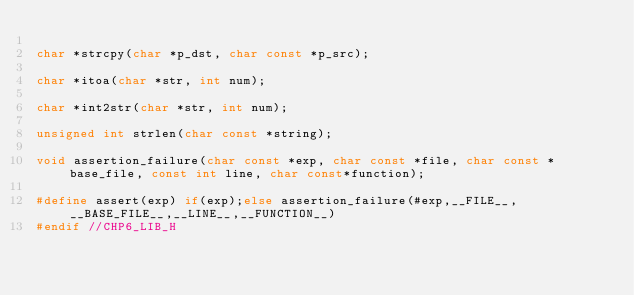<code> <loc_0><loc_0><loc_500><loc_500><_C_>
char *strcpy(char *p_dst, char const *p_src);

char *itoa(char *str, int num);

char *int2str(char *str, int num);

unsigned int strlen(char const *string);

void assertion_failure(char const *exp, char const *file, char const *base_file, const int line, char const*function);

#define assert(exp) if(exp);else assertion_failure(#exp,__FILE__,__BASE_FILE__,__LINE__,__FUNCTION__)
#endif //CHP6_LIB_H
</code> 